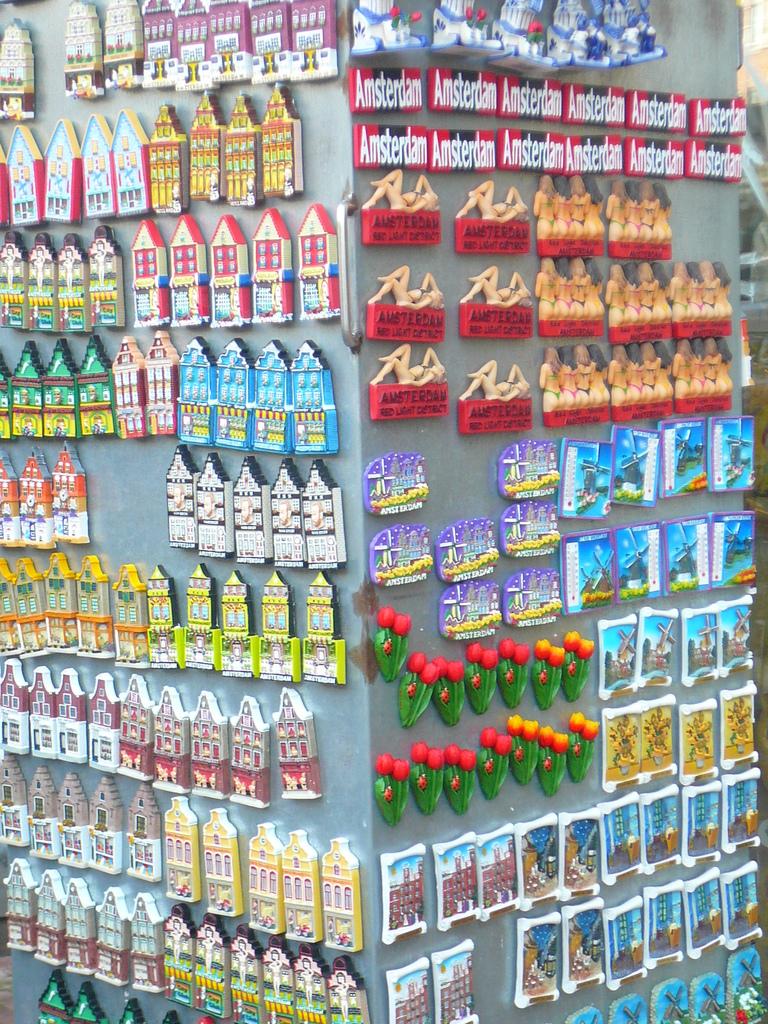Which city are the black and red magnets on the top for?
Provide a short and direct response. Amsterdam. 